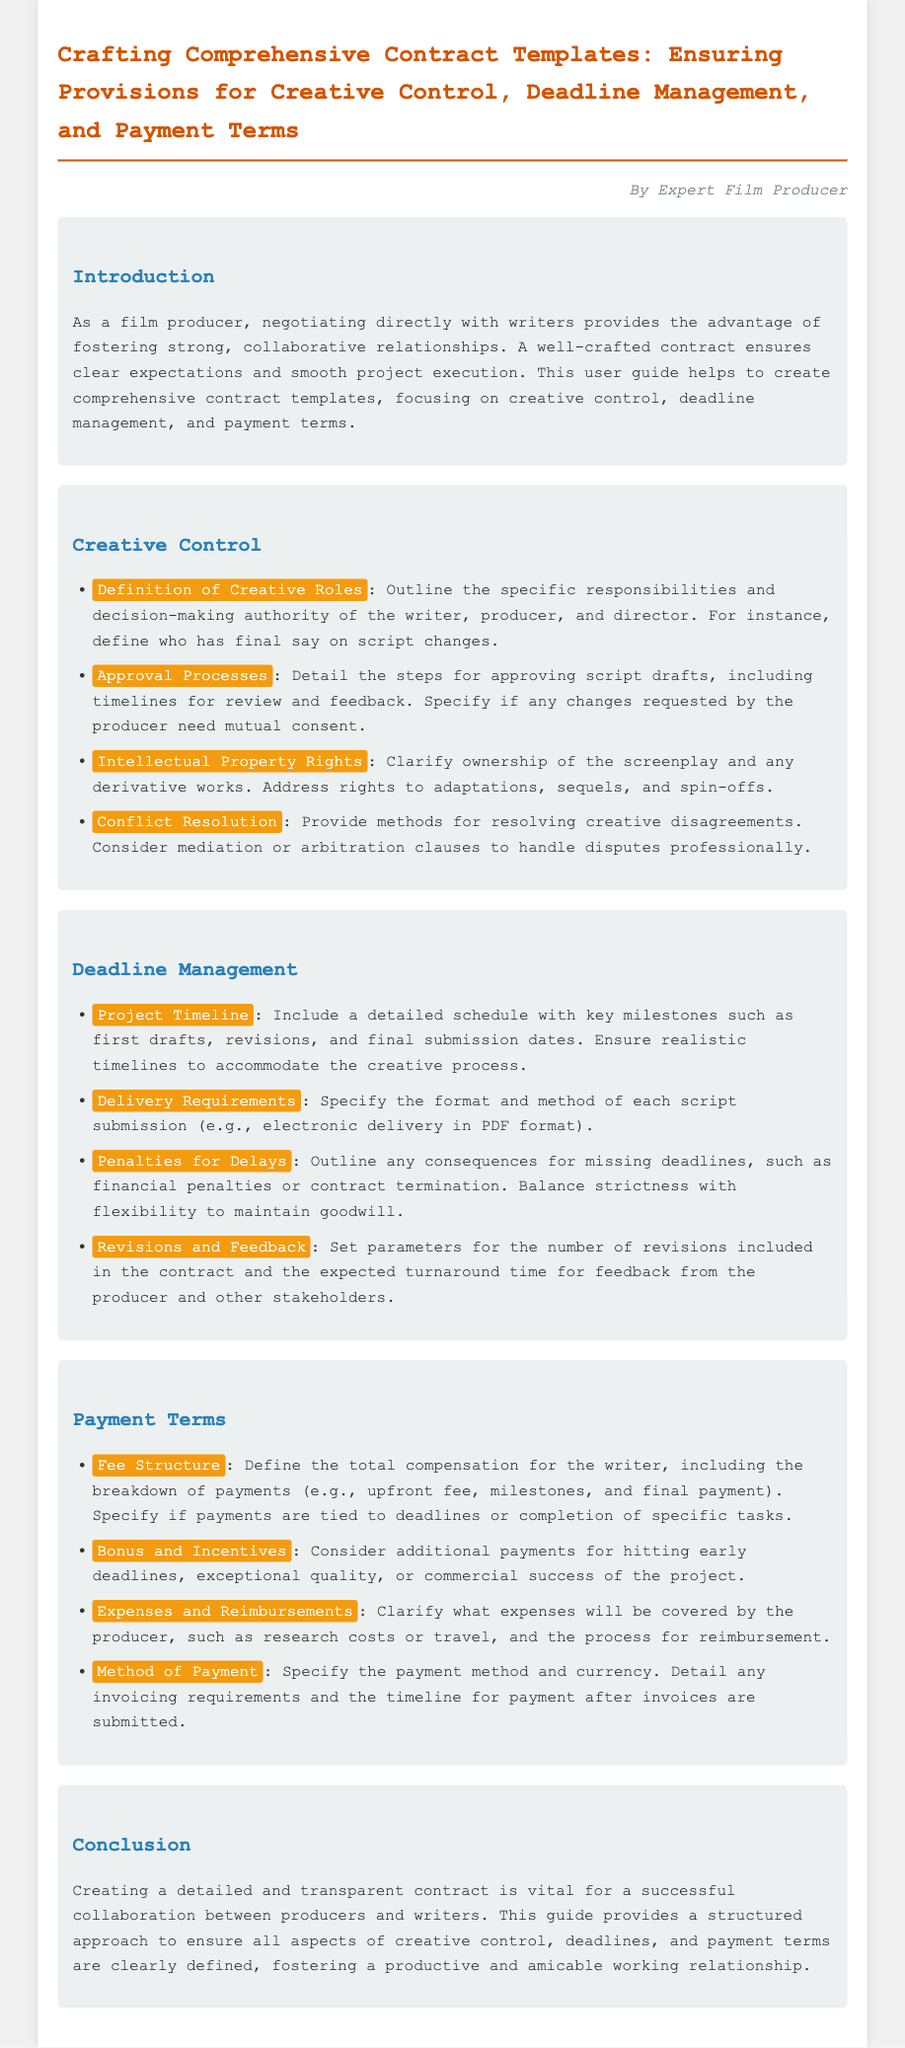what is the title of the document? The title of the document is the heading at the top of the rendered document.
Answer: Crafting Comprehensive Contract Templates: Ensuring Provisions for Creative Control, Deadline Management, and Payment Terms who is the author of the user guide? The author is mentioned in a separate paragraph under the title.
Answer: Expert Film Producer what section outlines the approval processes? The specific section that details the approval processes is clearly labeled in the document structure.
Answer: Creative Control how many key milestones are suggested for the project timeline? The section on deadline management describes what to include in the project timeline.
Answer: Key milestones such as first drafts, revisions, and final submission dates what consequences for delays are mentioned in the document? The document specifies the penalties in the section about deadline management.
Answer: Financial penalties or contract termination which section discusses bonus and incentives? The section that discusses additional compensation is clearly labeled in the document.
Answer: Payment Terms what type of expenses are covered by the producer? The payment terms section clarifies what kind of expenses the producer will cover.
Answer: Research costs or travel what is the purpose of the user guide? The purpose is stated at the beginning of the document in the introduction.
Answer: To create comprehensive contract templates how are conflicts resolved according to the user guide? The document mentions methods for resolving disputes in the creative control section.
Answer: Mediation or arbitration clauses 